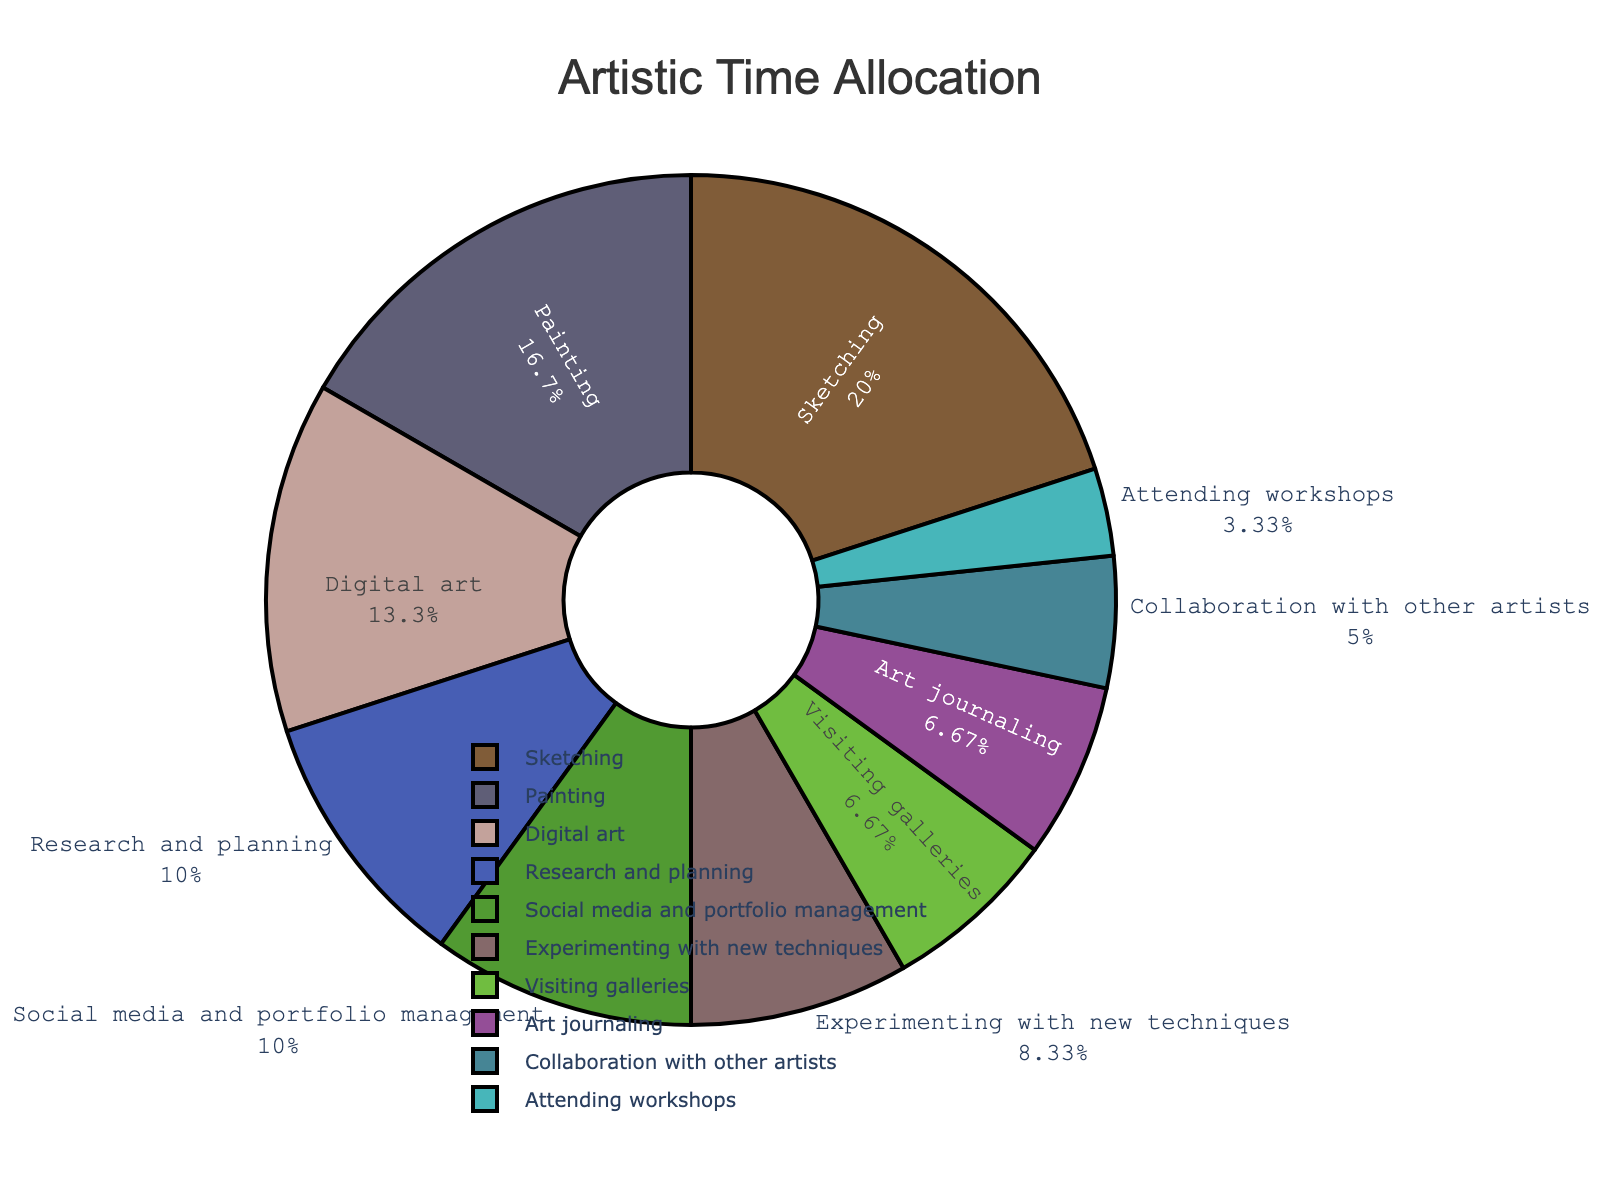How much time is spent on social media and portfolio management compared to attending workshops? To find how much more time is spent on social media and portfolio management compared to attending workshops, note the hours spent on both activities: 6 hours for social media and portfolio management and 2 hours for attending workshops. Subtracting the smaller value from the larger gives: 6 - 2 = 4 hours.
Answer: 4 hours What percentage of the week is spent on sketching? The pie chart provides the percentage directly as it often shows both the labels and their associated percentages. For sketching, look at its section of the pie chart and read the percentage listed.
Answer: 20% Which activity has the smallest allocation of time? Observe the pie chart and identify the smallest slice. According to the provided data, attending workshops has the smallest time allocation with 2 hours.
Answer: Attending workshops Is more time spent on visiting galleries or collaborating with other artists? Compare the slices for visiting galleries and collaborating with other artists. The pie chart shows that visiting galleries (4 hours) takes more time than collaborating with other artists (3 hours).
Answer: Visiting galleries What is the total time spent on activities related to learning and improvement (research and planning, experimenting, and attending workshops)? Add up the hours for research and planning (6 hours), experimenting with new techniques (5 hours), and attending workshops (2 hours): 6 + 5 + 2 = 13 hours.
Answer: 13 hours What is the combined percentage of time spent on digital art and art journaling? Check the pie chart for the percentages associated with digital art and art journaling. According to provided data, digital art takes 8 hours, and art journaling takes 4 hours. Add their times and convert to percentage: (8 + 4) / 50 = 24%.
Answer: 24% Which activity takes up more than 20% of the total time? Look at the pie chart for any activity with a slice covering more than 20% of the pie. According to the data, sketching (12 hours out of 50 hours total) takes up 24%.
Answer: Sketching What is the ratio of time spent on painting to the time spent on experimenting with new techniques? Find the hours spent on painting and experimenting with new techniques. Use the ratio: Painting (10 hours) to experimenting with new techniques (5 hours) is 10:5 or simplified, 2:1.
Answer: 2:1 What is the difference in time spent between the most and least time-consuming activities? Identify the most and least time-consuming activities: the most is sketching (12 hours), and the least is attending workshops (2 hours). Subtract to find the difference: 12 - 2 = 10 hours.
Answer: 10 hours 